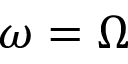Convert formula to latex. <formula><loc_0><loc_0><loc_500><loc_500>\omega = \Omega</formula> 